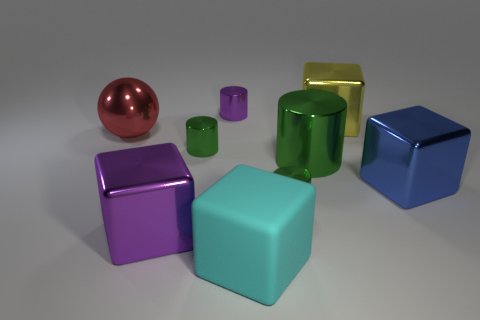Subtract all large metallic cylinders. How many cylinders are left? 3 Subtract all green cubes. How many green cylinders are left? 3 Subtract 1 blocks. How many blocks are left? 3 Subtract all purple cylinders. How many cylinders are left? 3 Subtract all cubes. How many objects are left? 5 Subtract all brown blocks. Subtract all green cylinders. How many blocks are left? 4 Subtract all small green objects. Subtract all shiny balls. How many objects are left? 6 Add 1 big metallic cylinders. How many big metallic cylinders are left? 2 Add 6 small purple cylinders. How many small purple cylinders exist? 7 Subtract 0 yellow cylinders. How many objects are left? 9 